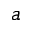<formula> <loc_0><loc_0><loc_500><loc_500>a</formula> 